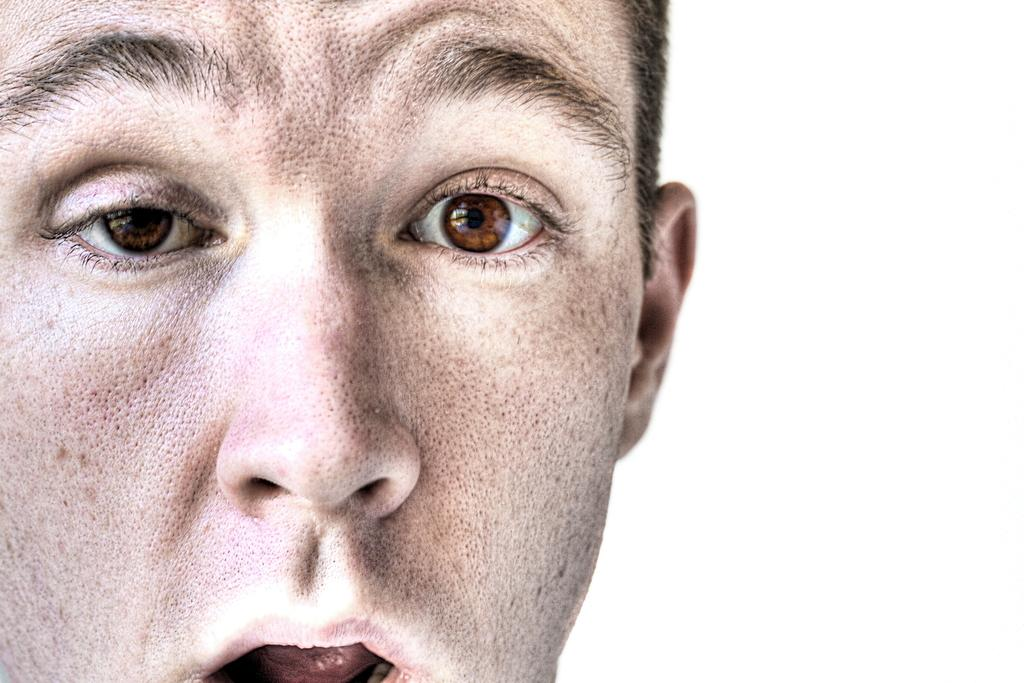What is the main subject of the image? There is a person's face in the image. What color is the background of the image? The background of the image is white. Can you describe the setting of the image? The image may have been taken in a room, as suggested by the white background. What type of goose can be seen in the image? There is no goose present in the image; it features a person's face. Can you tell me where the church is located in the image? There is no church present in the image; it features a person's face against a white background. 